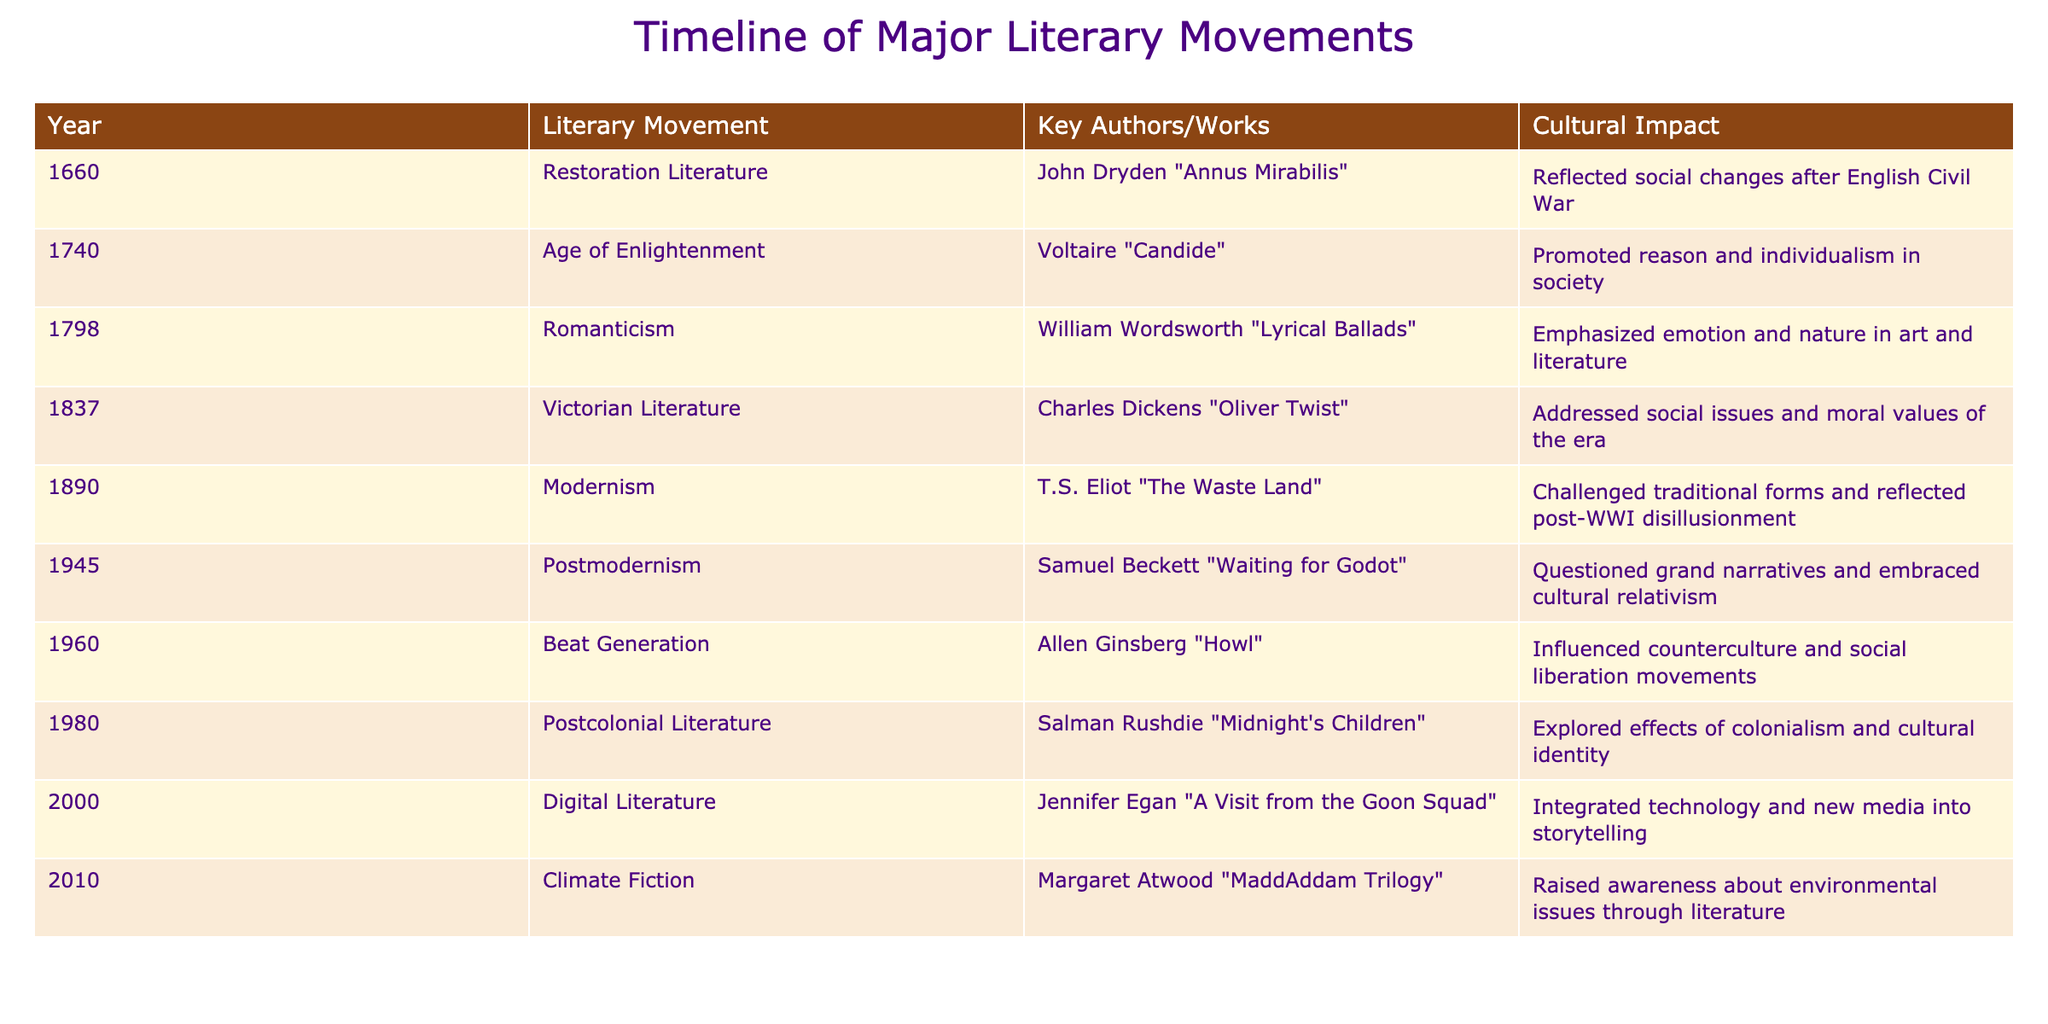What was the first literary movement included in the timeline? Looking at the 'Year' column, the earliest year listed is 1660, which corresponds to the 'Restoration Literature' movement. Thus, it is the first literary movement mentioned in the timeline.
Answer: Restoration Literature Which author is associated with Romanticism? The 'Key Authors/Works' column for the 'Romanticism' movement in 1798 lists William Wordsworth and his work "Lyrical Ballads". Therefore, he is the associated author for that movement.
Answer: William Wordsworth Did the Beat Generation influence social liberation movements? According to the 'Cultural Impact' column, the Beat Generation is explicitly mentioned to have influenced counterculture and social liberation movements. Thus, the statement is true.
Answer: Yes What is the difference in years between the publication of "Waiting for Godot" and "A Visit from the Goon Squad"? "Waiting for Godot" was released in 1945 and "A Visit from the Goon Squad" in 2000. The difference in years is 2000 - 1945 = 55 years.
Answer: 55 years Which literary movement focused on environmental issues? The 'Cultural Impact' column indicates that 'Climate Fiction', which began in 2010, raised awareness about environmental issues through literature. Thus, this movement focused on environmental themes.
Answer: Climate Fiction How many literary movements occurred in the 20th century? The timeline includes Modernism (1890), Postmodernism (1945), Beat Generation (1960), Postcolonial Literature (1980), and Digital Literature (2000). Counting these gives a total of five movements in the 20th century.
Answer: 5 Was "Oliver Twist" published during the Victorian Literature movement? According to the table, "Oliver Twist" was published in 1837, which is listed under the 'Victorian Literature' movement. Thus, the statement is true.
Answer: Yes What are the key themes addressed by the Victorian Literature movement? The 'Cultural Impact' column specifies that Victorian Literature addressed social issues and moral values of the era. Therefore, these are the key themes for this movement.
Answer: Social issues and moral values Which literary movement raised awareness about colonial effects? The table indicates that 'Postcolonial Literature' launched in 1980 explored the effects of colonialism and cultural identity, making it the movement related to this theme.
Answer: Postcolonial Literature 